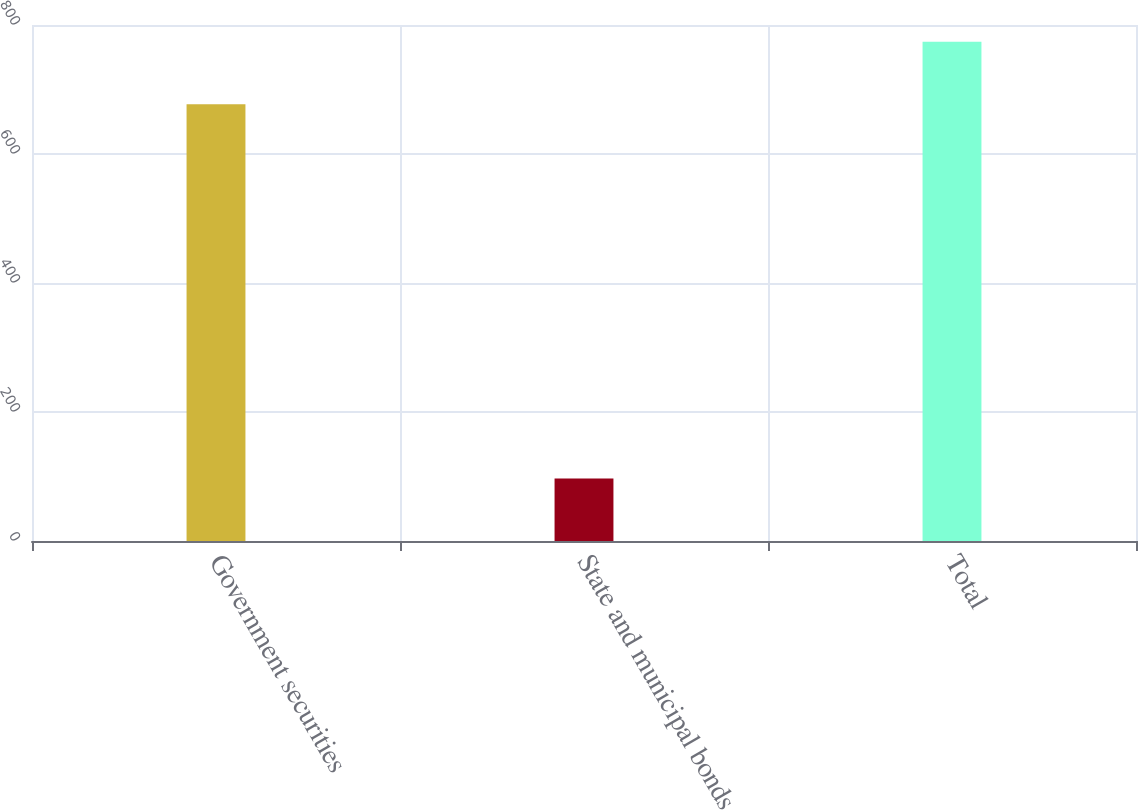Convert chart to OTSL. <chart><loc_0><loc_0><loc_500><loc_500><bar_chart><fcel>Government securities<fcel>State and municipal bonds<fcel>Total<nl><fcel>677<fcel>97<fcel>774<nl></chart> 